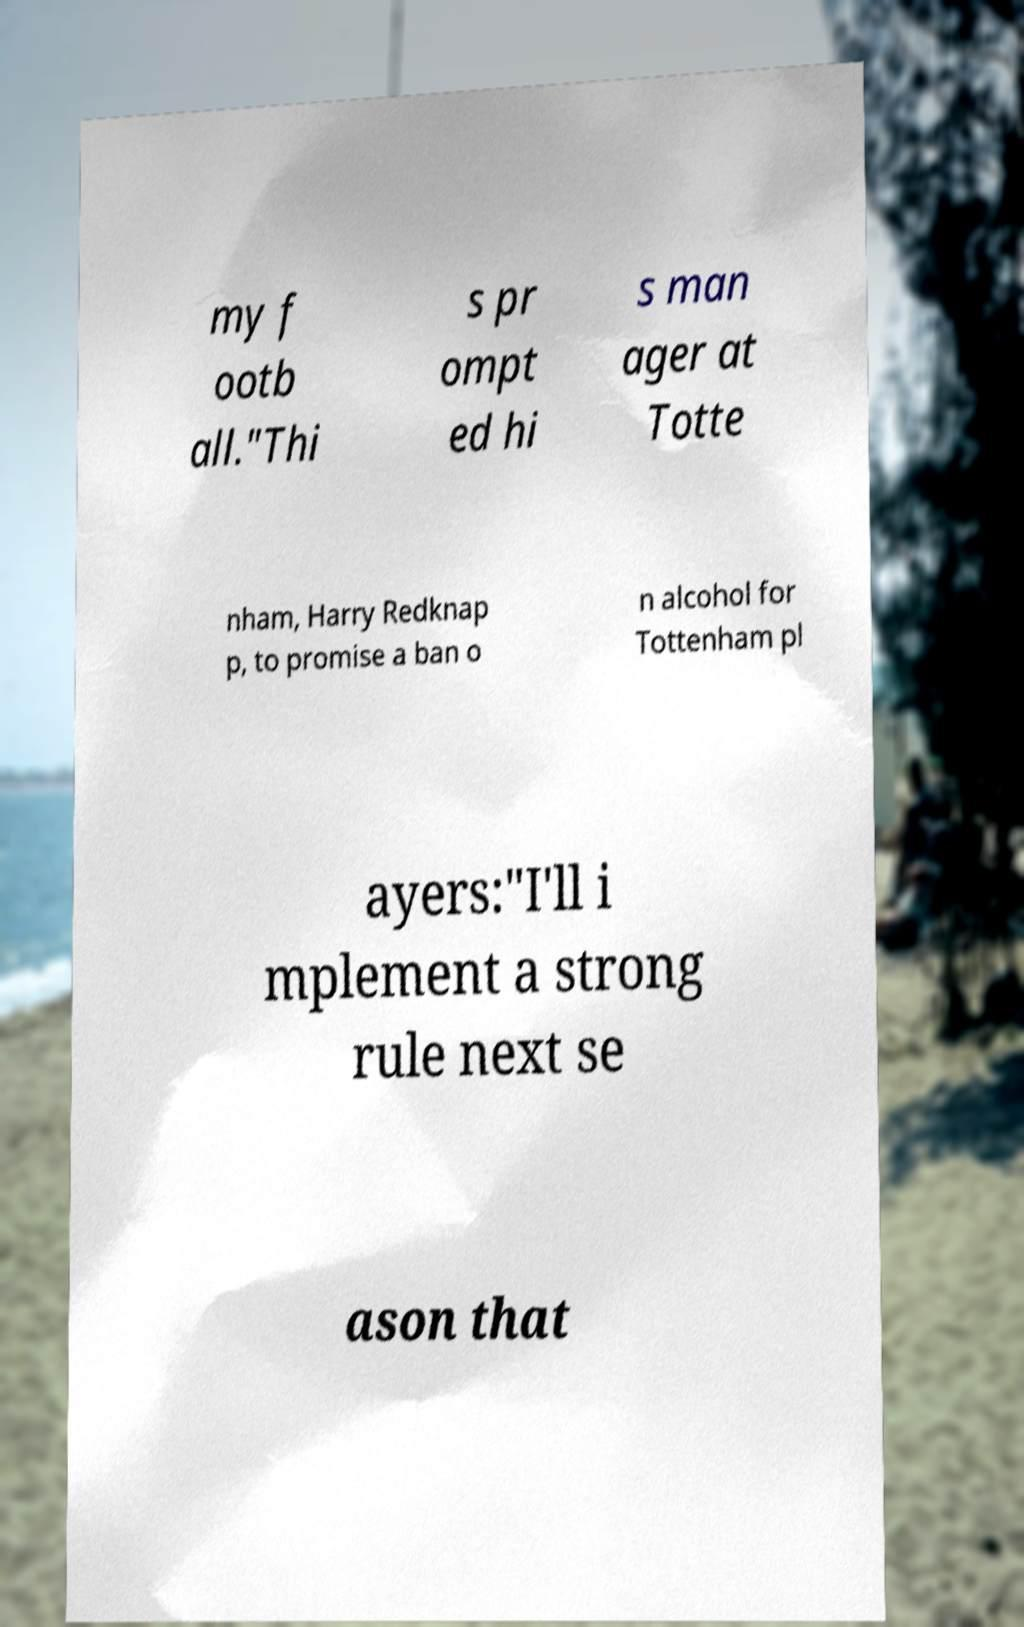For documentation purposes, I need the text within this image transcribed. Could you provide that? my f ootb all."Thi s pr ompt ed hi s man ager at Totte nham, Harry Redknap p, to promise a ban o n alcohol for Tottenham pl ayers:"I'll i mplement a strong rule next se ason that 